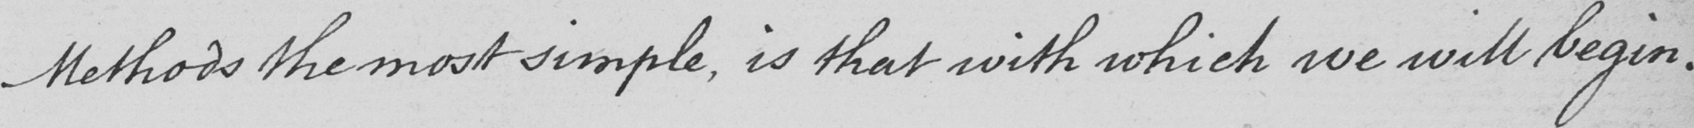Please provide the text content of this handwritten line. Methods the most simple , is that with which we will begin . 